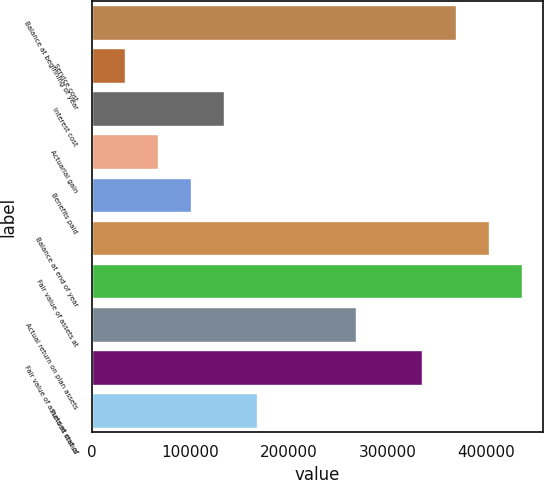Convert chart to OTSL. <chart><loc_0><loc_0><loc_500><loc_500><bar_chart><fcel>Balance at beginning of year<fcel>Service cost<fcel>Interest cost<fcel>Actuarial gain<fcel>Benefits paid<fcel>Balance at end of year<fcel>Fair value of assets at<fcel>Actual return on plan assets<fcel>Fair value of assets at end of<fcel>Funded status<nl><fcel>368626<fcel>34166<fcel>134504<fcel>67612<fcel>101058<fcel>402072<fcel>435518<fcel>268288<fcel>335180<fcel>167950<nl></chart> 